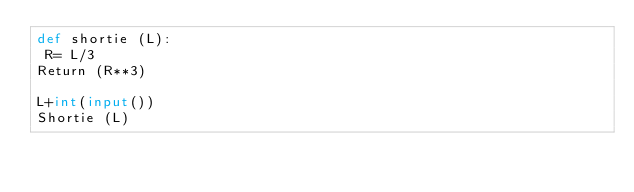<code> <loc_0><loc_0><loc_500><loc_500><_Python_>def shortie (L):
 R= L/3
Return (R**3)

L+int(input())
Shortie (L)</code> 